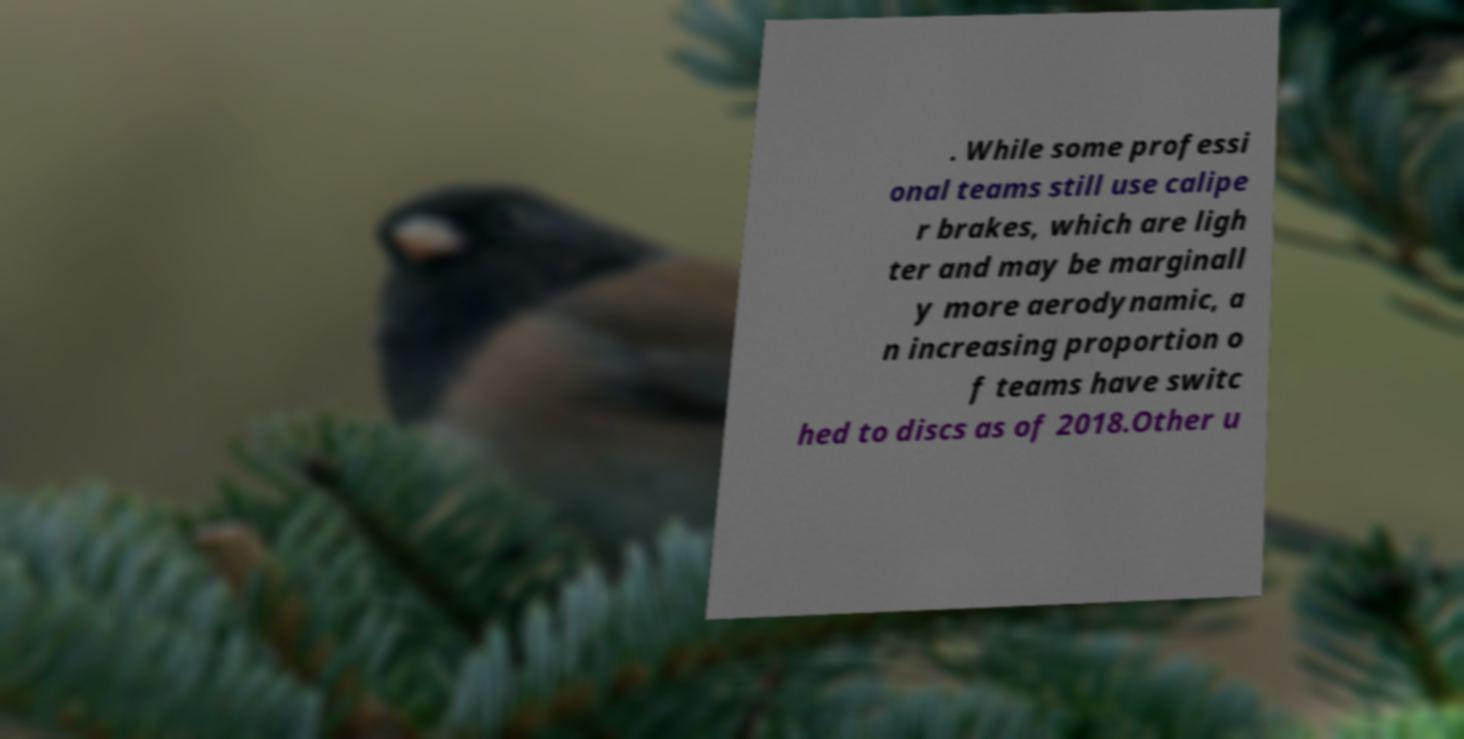Please read and relay the text visible in this image. What does it say? . While some professi onal teams still use calipe r brakes, which are ligh ter and may be marginall y more aerodynamic, a n increasing proportion o f teams have switc hed to discs as of 2018.Other u 